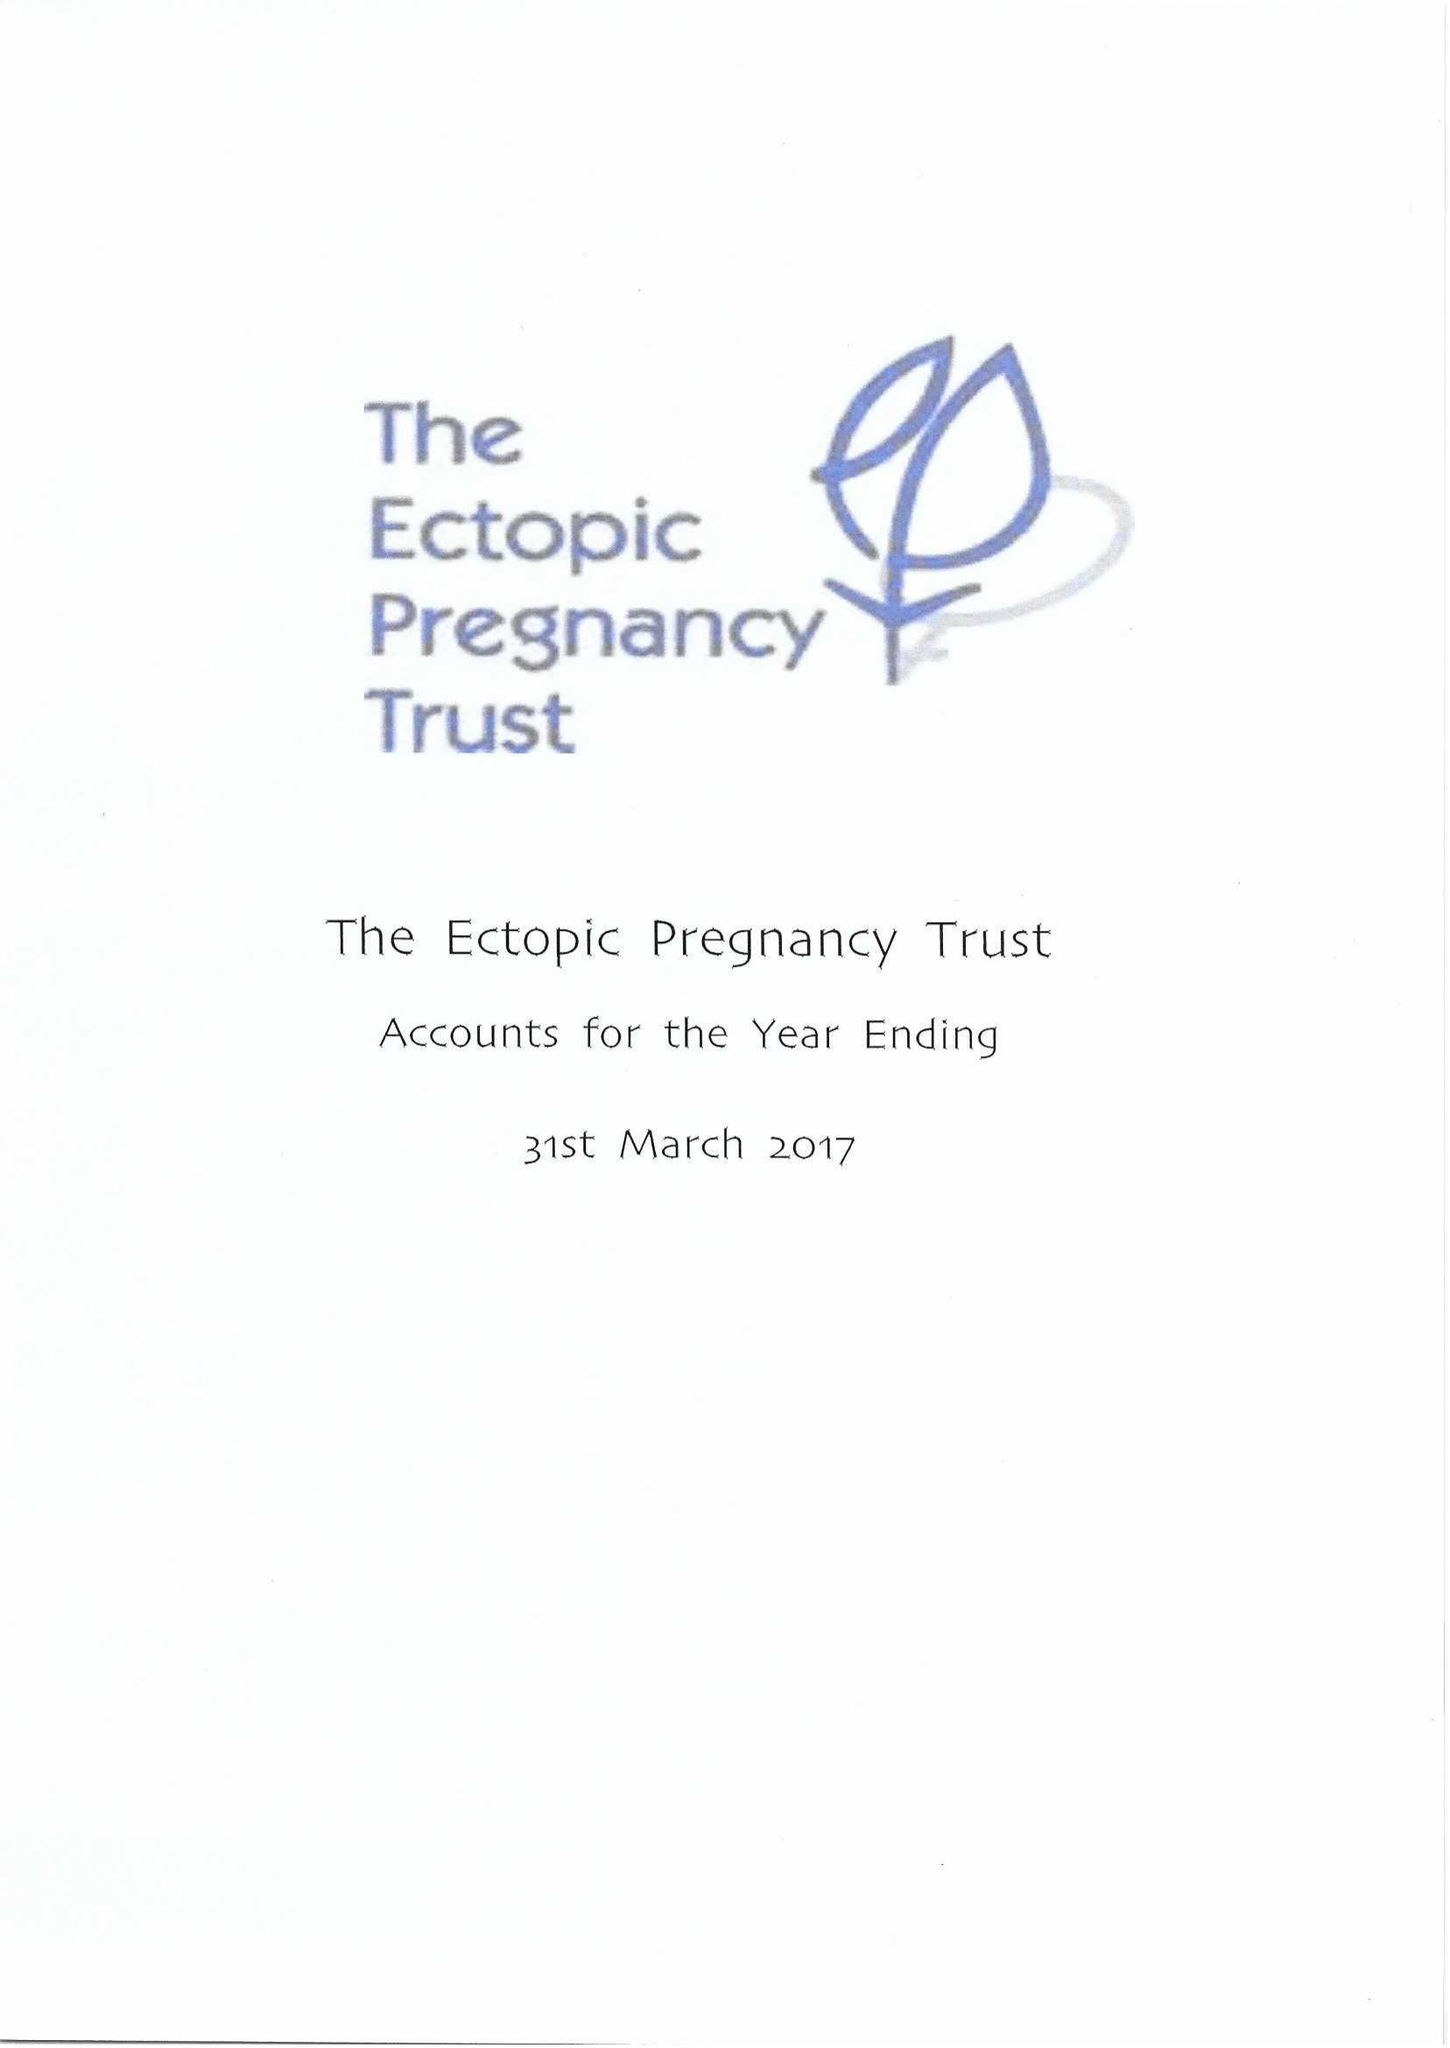What is the value for the address__post_town?
Answer the question using a single word or phrase. LONDON 